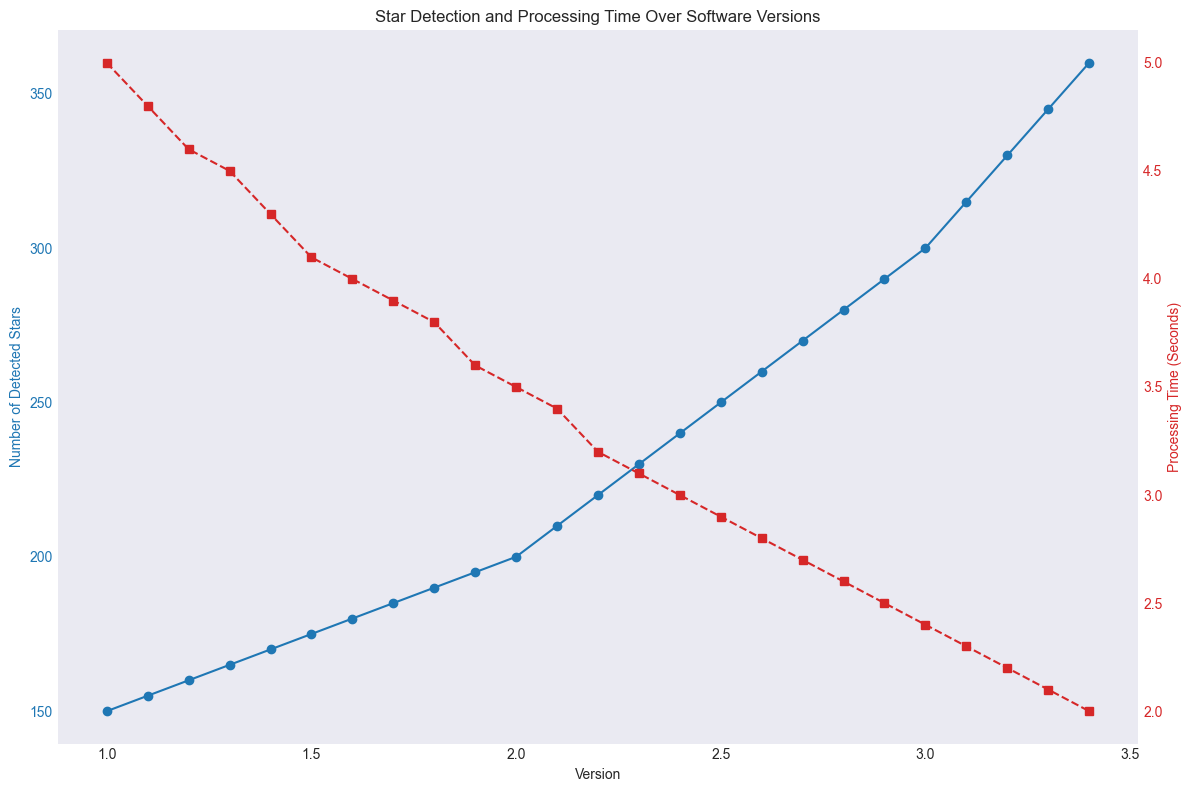What is the number of detected stars in version 2.0? The plot shows 'Number of Detected Stars' on the primary y-axis and 'Version' on the x-axis. Locate version 2.0 and find the corresponding number on the y-axis.
Answer: 200 What is the processing time in seconds for version 1.5? The plot shows 'Processing Time (Seconds)' on the secondary y-axis and 'Version' on the x-axis. Locate version 1.5 and find the corresponding number on the y-axis.
Answer: 4.1 How much did the number of detected stars increase between versions 1.0 and 3.4? Locate version 1.0 and version 3.4 on the x-axis. Read the corresponding values on the primary y-axis and find the difference between these two values.
Answer: 210 What is the average processing time for versions 3.0, 3.1, and 3.2? Locate versions 3.0, 3.1, and 3.2 on the x-axis. Sum the corresponding processing times read from the secondary y-axis, then divide by 3 to get the average.
Answer: \( (2.4 + 2.3 + 2.2)/3 = 2.3 \) Did the number of detected stars or processing time decrease more significantly as software versions improved? Observe the trend lines of both the number of detected stars (blue line) and processing time (red line). The blue line consistently increases while the red line consistently decreases. Note the steepness of the slopes and evaluate the relative change rates.
Answer: Processing Time Which version showed the highest number of detected stars? Locate the peak value on the primary y-axis corresponding to the version on the x-axis. The highest point indicates the version number with the most detected stars.
Answer: 3.4 By how many seconds did the processing time reduce from version 2.0 to version 3.0? Locate the processing times corresponding to versions 2.0 and 3.0 on the secondary y-axis. Subtract the later version's value from the earlier version's value.
Answer: 3.5 - 2.4 = 1.1 At which version did the processing time first go below 4 seconds? Track the downward trend line of processing time (red line) on the secondary y-axis and locate the first version that corresponds to a value below 4 seconds.
Answer: 1.6 Between which versions did we see the largest single jump in the number of detected stars? Compare the increments of detected stars across all consecutive versions using the primary y-axis and identify the largest jump.
Answer: Between versions 3.3 and 3.4 What is the difference in the number of detected stars between versions 2.5 and 3.1? Locate versions 2.5 and 3.1 on the x-axis. Read the corresponding detected stars on the primary y-axis and find the difference.
Answer: 250 - 315 = 65 